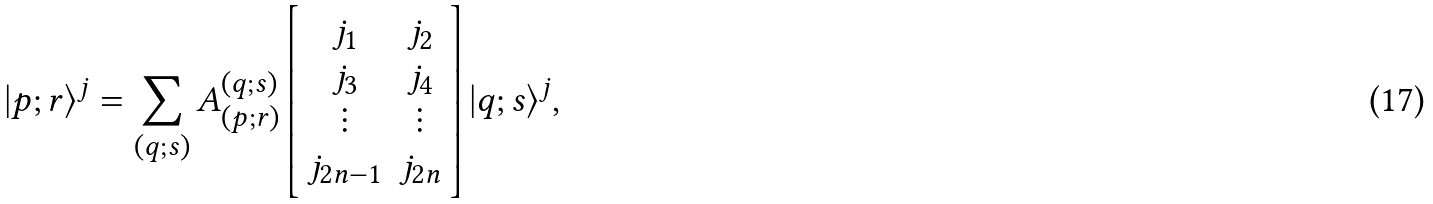<formula> <loc_0><loc_0><loc_500><loc_500>| { p } ; { r } \rangle ^ { j } = \sum _ { ( { q } ; { s } ) } A _ { ( { p } ; { r } ) } ^ { ( { q } ; { s } ) } \left [ \begin{array} { c c } j _ { 1 } & j _ { 2 } \\ j _ { 3 } & j _ { 4 } \\ \vdots & \vdots \\ j _ { 2 n - 1 } & j _ { 2 n } \end{array} \right ] | { q } ; { s } \rangle ^ { j } ,</formula> 